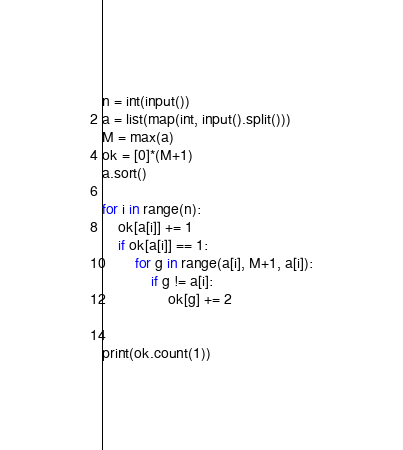<code> <loc_0><loc_0><loc_500><loc_500><_Python_>n = int(input())
a = list(map(int, input().split()))
M = max(a)
ok = [0]*(M+1)
a.sort()

for i in range(n):
    ok[a[i]] += 1
    if ok[a[i]] == 1:
        for g in range(a[i], M+1, a[i]):
            if g != a[i]:
                ok[g] += 2


print(ok.count(1))</code> 